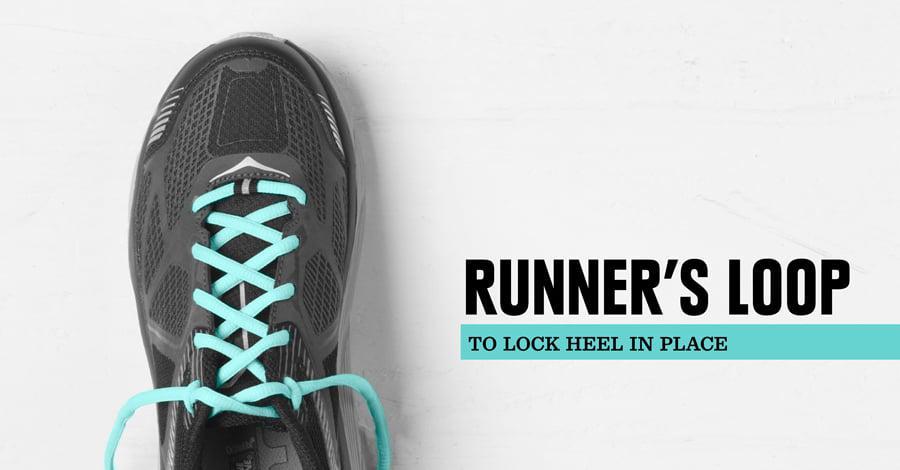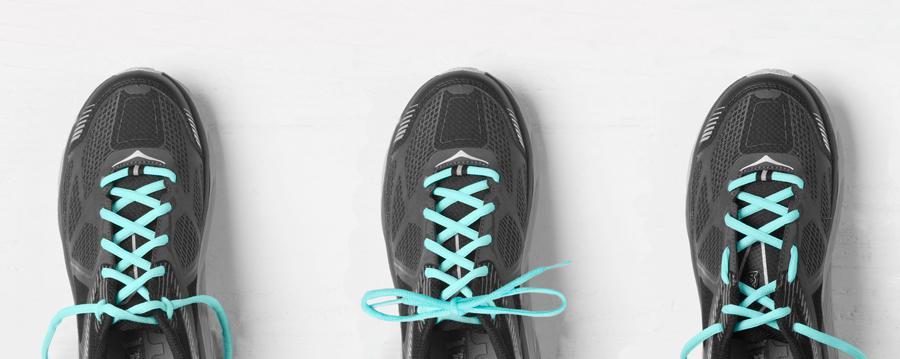The first image is the image on the left, the second image is the image on the right. For the images shown, is this caption "There is a total of four shoes." true? Answer yes or no. Yes. The first image is the image on the left, the second image is the image on the right. Examine the images to the left and right. Is the description "All of the shoes shown have the same color laces." accurate? Answer yes or no. Yes. 